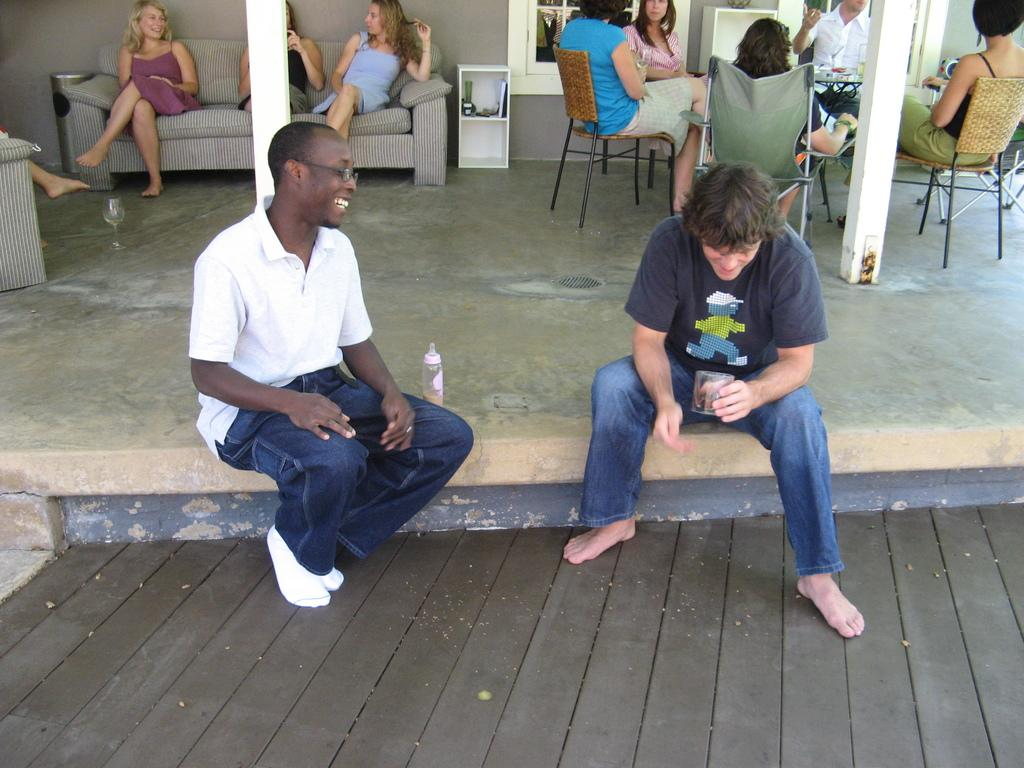What are the two people in the foreground of the image doing? The two people are sitting on the floor. What can be seen in the background of the image? There are people sitting on sofas and at a round table in the background. What type of crown is being worn by the person sitting at the round table in the image? There is no crown visible in the image; no one is wearing a crown. What mountain range can be seen in the background of the image? There is no mountain range present in the image. 